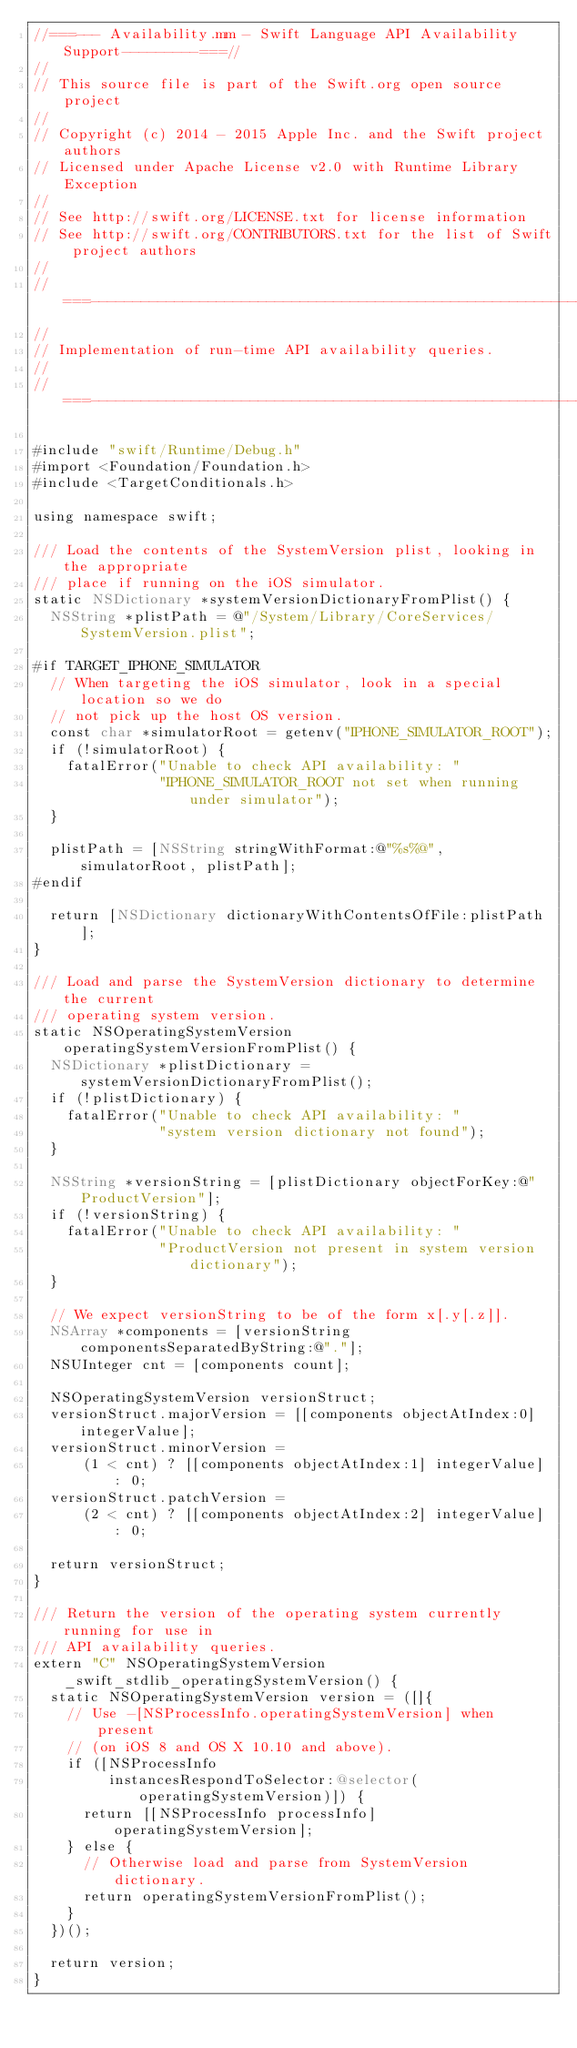<code> <loc_0><loc_0><loc_500><loc_500><_ObjectiveC_>//===--- Availability.mm - Swift Language API Availability Support---------===//
//
// This source file is part of the Swift.org open source project
//
// Copyright (c) 2014 - 2015 Apple Inc. and the Swift project authors
// Licensed under Apache License v2.0 with Runtime Library Exception
//
// See http://swift.org/LICENSE.txt for license information
// See http://swift.org/CONTRIBUTORS.txt for the list of Swift project authors
//
//===----------------------------------------------------------------------===//
//
// Implementation of run-time API availability queries.
//
//===----------------------------------------------------------------------===//

#include "swift/Runtime/Debug.h"
#import <Foundation/Foundation.h>
#include <TargetConditionals.h>

using namespace swift;

/// Load the contents of the SystemVersion plist, looking in the appropriate
/// place if running on the iOS simulator.
static NSDictionary *systemVersionDictionaryFromPlist() {
  NSString *plistPath = @"/System/Library/CoreServices/SystemVersion.plist";

#if TARGET_IPHONE_SIMULATOR
  // When targeting the iOS simulator, look in a special location so we do
  // not pick up the host OS version.
  const char *simulatorRoot = getenv("IPHONE_SIMULATOR_ROOT");
  if (!simulatorRoot) {
    fatalError("Unable to check API availability: "
               "IPHONE_SIMULATOR_ROOT not set when running under simulator");
  }

  plistPath = [NSString stringWithFormat:@"%s%@", simulatorRoot, plistPath];
#endif

  return [NSDictionary dictionaryWithContentsOfFile:plistPath];
}

/// Load and parse the SystemVersion dictionary to determine the current
/// operating system version.
static NSOperatingSystemVersion operatingSystemVersionFromPlist() {
  NSDictionary *plistDictionary = systemVersionDictionaryFromPlist();
  if (!plistDictionary) {
    fatalError("Unable to check API availability: "
               "system version dictionary not found");
  }

  NSString *versionString = [plistDictionary objectForKey:@"ProductVersion"];
  if (!versionString) {
    fatalError("Unable to check API availability: "
               "ProductVersion not present in system version dictionary");
  }

  // We expect versionString to be of the form x[.y[.z]].
  NSArray *components = [versionString componentsSeparatedByString:@"."];
  NSUInteger cnt = [components count];

  NSOperatingSystemVersion versionStruct;
  versionStruct.majorVersion = [[components objectAtIndex:0] integerValue];
  versionStruct.minorVersion =
      (1 < cnt) ? [[components objectAtIndex:1] integerValue] : 0;
  versionStruct.patchVersion =
      (2 < cnt) ? [[components objectAtIndex:2] integerValue] : 0;

  return versionStruct;
}

/// Return the version of the operating system currently running for use in
/// API availability queries.
extern "C" NSOperatingSystemVersion _swift_stdlib_operatingSystemVersion() {
  static NSOperatingSystemVersion version = ([]{
    // Use -[NSProcessInfo.operatingSystemVersion] when present
    // (on iOS 8 and OS X 10.10 and above).
    if ([NSProcessInfo
         instancesRespondToSelector:@selector(operatingSystemVersion)]) {
      return [[NSProcessInfo processInfo] operatingSystemVersion];
    } else {
      // Otherwise load and parse from SystemVersion dictionary.
      return operatingSystemVersionFromPlist();
    }
  })();

  return version;
}
</code> 